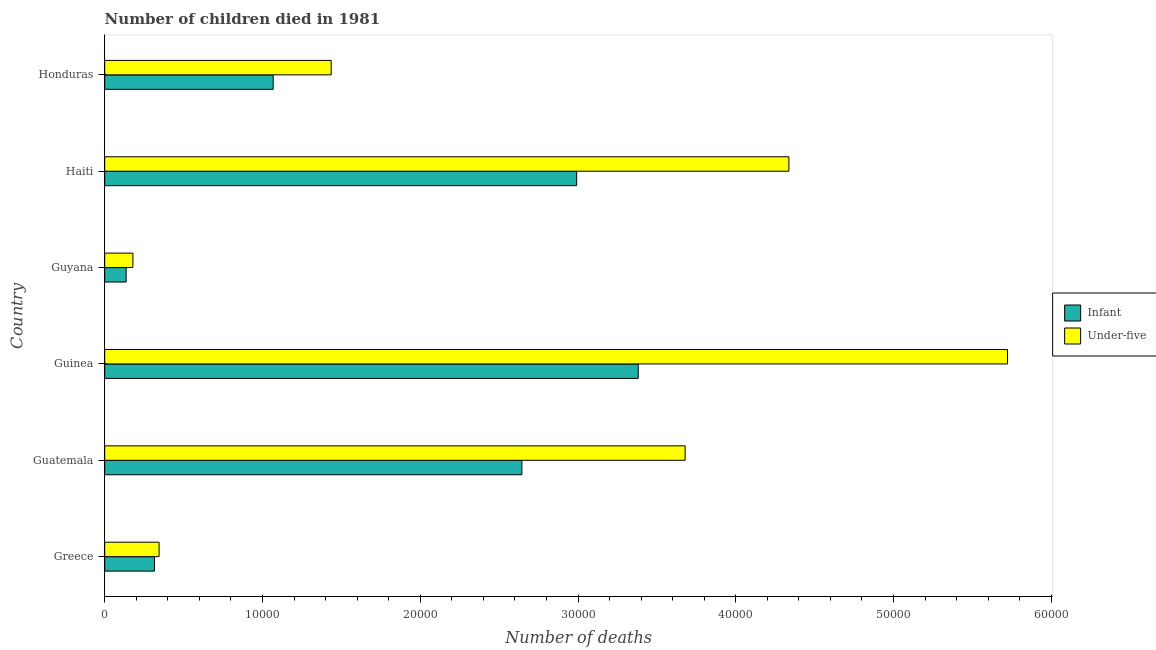How many different coloured bars are there?
Your answer should be compact. 2. Are the number of bars on each tick of the Y-axis equal?
Your answer should be very brief. Yes. What is the label of the 2nd group of bars from the top?
Provide a succinct answer. Haiti. What is the number of under-five deaths in Greece?
Your response must be concise. 3447. Across all countries, what is the maximum number of under-five deaths?
Make the answer very short. 5.72e+04. Across all countries, what is the minimum number of under-five deaths?
Keep it short and to the point. 1786. In which country was the number of under-five deaths maximum?
Your answer should be very brief. Guinea. In which country was the number of infant deaths minimum?
Provide a short and direct response. Guyana. What is the total number of under-five deaths in the graph?
Your response must be concise. 1.57e+05. What is the difference between the number of under-five deaths in Guatemala and that in Haiti?
Offer a terse response. -6578. What is the difference between the number of under-five deaths in Guatemala and the number of infant deaths in Greece?
Keep it short and to the point. 3.36e+04. What is the average number of under-five deaths per country?
Your answer should be very brief. 2.62e+04. What is the difference between the number of infant deaths and number of under-five deaths in Guinea?
Offer a very short reply. -2.34e+04. What is the ratio of the number of under-five deaths in Guinea to that in Haiti?
Ensure brevity in your answer.  1.32. Is the number of under-five deaths in Guatemala less than that in Honduras?
Make the answer very short. No. Is the difference between the number of infant deaths in Guinea and Haiti greater than the difference between the number of under-five deaths in Guinea and Haiti?
Your answer should be compact. No. What is the difference between the highest and the second highest number of under-five deaths?
Ensure brevity in your answer.  1.39e+04. What is the difference between the highest and the lowest number of infant deaths?
Provide a short and direct response. 3.25e+04. What does the 1st bar from the top in Guatemala represents?
Give a very brief answer. Under-five. What does the 2nd bar from the bottom in Guyana represents?
Make the answer very short. Under-five. Are all the bars in the graph horizontal?
Keep it short and to the point. Yes. What is the difference between two consecutive major ticks on the X-axis?
Provide a short and direct response. 10000. Are the values on the major ticks of X-axis written in scientific E-notation?
Your answer should be very brief. No. Does the graph contain any zero values?
Offer a terse response. No. Where does the legend appear in the graph?
Your response must be concise. Center right. How many legend labels are there?
Ensure brevity in your answer.  2. How are the legend labels stacked?
Offer a terse response. Vertical. What is the title of the graph?
Offer a very short reply. Number of children died in 1981. Does "Merchandise exports" appear as one of the legend labels in the graph?
Give a very brief answer. No. What is the label or title of the X-axis?
Your answer should be very brief. Number of deaths. What is the label or title of the Y-axis?
Your response must be concise. Country. What is the Number of deaths in Infant in Greece?
Keep it short and to the point. 3154. What is the Number of deaths of Under-five in Greece?
Your answer should be very brief. 3447. What is the Number of deaths of Infant in Guatemala?
Give a very brief answer. 2.64e+04. What is the Number of deaths in Under-five in Guatemala?
Give a very brief answer. 3.68e+04. What is the Number of deaths in Infant in Guinea?
Offer a very short reply. 3.38e+04. What is the Number of deaths of Under-five in Guinea?
Provide a short and direct response. 5.72e+04. What is the Number of deaths in Infant in Guyana?
Ensure brevity in your answer.  1359. What is the Number of deaths of Under-five in Guyana?
Offer a very short reply. 1786. What is the Number of deaths in Infant in Haiti?
Offer a terse response. 2.99e+04. What is the Number of deaths of Under-five in Haiti?
Provide a short and direct response. 4.34e+04. What is the Number of deaths in Infant in Honduras?
Offer a terse response. 1.07e+04. What is the Number of deaths in Under-five in Honduras?
Offer a very short reply. 1.44e+04. Across all countries, what is the maximum Number of deaths in Infant?
Provide a succinct answer. 3.38e+04. Across all countries, what is the maximum Number of deaths of Under-five?
Provide a short and direct response. 5.72e+04. Across all countries, what is the minimum Number of deaths in Infant?
Keep it short and to the point. 1359. Across all countries, what is the minimum Number of deaths in Under-five?
Your answer should be very brief. 1786. What is the total Number of deaths of Infant in the graph?
Your response must be concise. 1.05e+05. What is the total Number of deaths in Under-five in the graph?
Make the answer very short. 1.57e+05. What is the difference between the Number of deaths in Infant in Greece and that in Guatemala?
Provide a short and direct response. -2.33e+04. What is the difference between the Number of deaths in Under-five in Greece and that in Guatemala?
Keep it short and to the point. -3.33e+04. What is the difference between the Number of deaths in Infant in Greece and that in Guinea?
Keep it short and to the point. -3.07e+04. What is the difference between the Number of deaths in Under-five in Greece and that in Guinea?
Make the answer very short. -5.38e+04. What is the difference between the Number of deaths of Infant in Greece and that in Guyana?
Offer a terse response. 1795. What is the difference between the Number of deaths of Under-five in Greece and that in Guyana?
Keep it short and to the point. 1661. What is the difference between the Number of deaths in Infant in Greece and that in Haiti?
Your answer should be very brief. -2.68e+04. What is the difference between the Number of deaths of Under-five in Greece and that in Haiti?
Your answer should be very brief. -3.99e+04. What is the difference between the Number of deaths in Infant in Greece and that in Honduras?
Make the answer very short. -7524. What is the difference between the Number of deaths in Under-five in Greece and that in Honduras?
Your response must be concise. -1.09e+04. What is the difference between the Number of deaths of Infant in Guatemala and that in Guinea?
Your response must be concise. -7377. What is the difference between the Number of deaths in Under-five in Guatemala and that in Guinea?
Your response must be concise. -2.04e+04. What is the difference between the Number of deaths in Infant in Guatemala and that in Guyana?
Your answer should be compact. 2.51e+04. What is the difference between the Number of deaths in Under-five in Guatemala and that in Guyana?
Your response must be concise. 3.50e+04. What is the difference between the Number of deaths of Infant in Guatemala and that in Haiti?
Your response must be concise. -3473. What is the difference between the Number of deaths of Under-five in Guatemala and that in Haiti?
Provide a short and direct response. -6578. What is the difference between the Number of deaths in Infant in Guatemala and that in Honduras?
Keep it short and to the point. 1.58e+04. What is the difference between the Number of deaths of Under-five in Guatemala and that in Honduras?
Give a very brief answer. 2.24e+04. What is the difference between the Number of deaths of Infant in Guinea and that in Guyana?
Ensure brevity in your answer.  3.25e+04. What is the difference between the Number of deaths of Under-five in Guinea and that in Guyana?
Ensure brevity in your answer.  5.54e+04. What is the difference between the Number of deaths of Infant in Guinea and that in Haiti?
Offer a terse response. 3904. What is the difference between the Number of deaths of Under-five in Guinea and that in Haiti?
Provide a short and direct response. 1.39e+04. What is the difference between the Number of deaths of Infant in Guinea and that in Honduras?
Your response must be concise. 2.31e+04. What is the difference between the Number of deaths of Under-five in Guinea and that in Honduras?
Ensure brevity in your answer.  4.29e+04. What is the difference between the Number of deaths in Infant in Guyana and that in Haiti?
Give a very brief answer. -2.86e+04. What is the difference between the Number of deaths of Under-five in Guyana and that in Haiti?
Your answer should be very brief. -4.16e+04. What is the difference between the Number of deaths in Infant in Guyana and that in Honduras?
Offer a very short reply. -9319. What is the difference between the Number of deaths of Under-five in Guyana and that in Honduras?
Your response must be concise. -1.26e+04. What is the difference between the Number of deaths of Infant in Haiti and that in Honduras?
Your answer should be compact. 1.92e+04. What is the difference between the Number of deaths of Under-five in Haiti and that in Honduras?
Provide a short and direct response. 2.90e+04. What is the difference between the Number of deaths of Infant in Greece and the Number of deaths of Under-five in Guatemala?
Make the answer very short. -3.36e+04. What is the difference between the Number of deaths in Infant in Greece and the Number of deaths in Under-five in Guinea?
Give a very brief answer. -5.41e+04. What is the difference between the Number of deaths of Infant in Greece and the Number of deaths of Under-five in Guyana?
Your answer should be very brief. 1368. What is the difference between the Number of deaths in Infant in Greece and the Number of deaths in Under-five in Haiti?
Provide a short and direct response. -4.02e+04. What is the difference between the Number of deaths of Infant in Greece and the Number of deaths of Under-five in Honduras?
Give a very brief answer. -1.12e+04. What is the difference between the Number of deaths of Infant in Guatemala and the Number of deaths of Under-five in Guinea?
Ensure brevity in your answer.  -3.08e+04. What is the difference between the Number of deaths in Infant in Guatemala and the Number of deaths in Under-five in Guyana?
Make the answer very short. 2.47e+04. What is the difference between the Number of deaths of Infant in Guatemala and the Number of deaths of Under-five in Haiti?
Make the answer very short. -1.69e+04. What is the difference between the Number of deaths of Infant in Guatemala and the Number of deaths of Under-five in Honduras?
Make the answer very short. 1.21e+04. What is the difference between the Number of deaths of Infant in Guinea and the Number of deaths of Under-five in Guyana?
Your answer should be compact. 3.20e+04. What is the difference between the Number of deaths of Infant in Guinea and the Number of deaths of Under-five in Haiti?
Keep it short and to the point. -9549. What is the difference between the Number of deaths of Infant in Guinea and the Number of deaths of Under-five in Honduras?
Give a very brief answer. 1.95e+04. What is the difference between the Number of deaths in Infant in Guyana and the Number of deaths in Under-five in Haiti?
Provide a succinct answer. -4.20e+04. What is the difference between the Number of deaths of Infant in Guyana and the Number of deaths of Under-five in Honduras?
Ensure brevity in your answer.  -1.30e+04. What is the difference between the Number of deaths of Infant in Haiti and the Number of deaths of Under-five in Honduras?
Your response must be concise. 1.56e+04. What is the average Number of deaths of Infant per country?
Provide a short and direct response. 1.76e+04. What is the average Number of deaths in Under-five per country?
Give a very brief answer. 2.62e+04. What is the difference between the Number of deaths of Infant and Number of deaths of Under-five in Greece?
Make the answer very short. -293. What is the difference between the Number of deaths in Infant and Number of deaths in Under-five in Guatemala?
Your answer should be very brief. -1.03e+04. What is the difference between the Number of deaths in Infant and Number of deaths in Under-five in Guinea?
Provide a succinct answer. -2.34e+04. What is the difference between the Number of deaths in Infant and Number of deaths in Under-five in Guyana?
Offer a very short reply. -427. What is the difference between the Number of deaths in Infant and Number of deaths in Under-five in Haiti?
Your answer should be compact. -1.35e+04. What is the difference between the Number of deaths in Infant and Number of deaths in Under-five in Honduras?
Provide a short and direct response. -3676. What is the ratio of the Number of deaths in Infant in Greece to that in Guatemala?
Keep it short and to the point. 0.12. What is the ratio of the Number of deaths of Under-five in Greece to that in Guatemala?
Keep it short and to the point. 0.09. What is the ratio of the Number of deaths in Infant in Greece to that in Guinea?
Offer a very short reply. 0.09. What is the ratio of the Number of deaths of Under-five in Greece to that in Guinea?
Your answer should be compact. 0.06. What is the ratio of the Number of deaths of Infant in Greece to that in Guyana?
Ensure brevity in your answer.  2.32. What is the ratio of the Number of deaths of Under-five in Greece to that in Guyana?
Your answer should be very brief. 1.93. What is the ratio of the Number of deaths of Infant in Greece to that in Haiti?
Your response must be concise. 0.11. What is the ratio of the Number of deaths in Under-five in Greece to that in Haiti?
Keep it short and to the point. 0.08. What is the ratio of the Number of deaths of Infant in Greece to that in Honduras?
Give a very brief answer. 0.3. What is the ratio of the Number of deaths in Under-five in Greece to that in Honduras?
Provide a succinct answer. 0.24. What is the ratio of the Number of deaths of Infant in Guatemala to that in Guinea?
Ensure brevity in your answer.  0.78. What is the ratio of the Number of deaths of Under-five in Guatemala to that in Guinea?
Keep it short and to the point. 0.64. What is the ratio of the Number of deaths in Infant in Guatemala to that in Guyana?
Your answer should be compact. 19.46. What is the ratio of the Number of deaths in Under-five in Guatemala to that in Guyana?
Provide a short and direct response. 20.6. What is the ratio of the Number of deaths of Infant in Guatemala to that in Haiti?
Your answer should be compact. 0.88. What is the ratio of the Number of deaths of Under-five in Guatemala to that in Haiti?
Ensure brevity in your answer.  0.85. What is the ratio of the Number of deaths in Infant in Guatemala to that in Honduras?
Make the answer very short. 2.48. What is the ratio of the Number of deaths of Under-five in Guatemala to that in Honduras?
Your response must be concise. 2.56. What is the ratio of the Number of deaths in Infant in Guinea to that in Guyana?
Provide a succinct answer. 24.89. What is the ratio of the Number of deaths of Under-five in Guinea to that in Guyana?
Your answer should be very brief. 32.04. What is the ratio of the Number of deaths in Infant in Guinea to that in Haiti?
Provide a succinct answer. 1.13. What is the ratio of the Number of deaths in Under-five in Guinea to that in Haiti?
Your answer should be compact. 1.32. What is the ratio of the Number of deaths of Infant in Guinea to that in Honduras?
Offer a very short reply. 3.17. What is the ratio of the Number of deaths in Under-five in Guinea to that in Honduras?
Your response must be concise. 3.99. What is the ratio of the Number of deaths in Infant in Guyana to that in Haiti?
Offer a terse response. 0.05. What is the ratio of the Number of deaths of Under-five in Guyana to that in Haiti?
Offer a terse response. 0.04. What is the ratio of the Number of deaths in Infant in Guyana to that in Honduras?
Provide a succinct answer. 0.13. What is the ratio of the Number of deaths in Under-five in Guyana to that in Honduras?
Your response must be concise. 0.12. What is the ratio of the Number of deaths of Infant in Haiti to that in Honduras?
Provide a succinct answer. 2.8. What is the ratio of the Number of deaths in Under-five in Haiti to that in Honduras?
Your answer should be compact. 3.02. What is the difference between the highest and the second highest Number of deaths of Infant?
Make the answer very short. 3904. What is the difference between the highest and the second highest Number of deaths in Under-five?
Ensure brevity in your answer.  1.39e+04. What is the difference between the highest and the lowest Number of deaths in Infant?
Offer a very short reply. 3.25e+04. What is the difference between the highest and the lowest Number of deaths of Under-five?
Provide a succinct answer. 5.54e+04. 